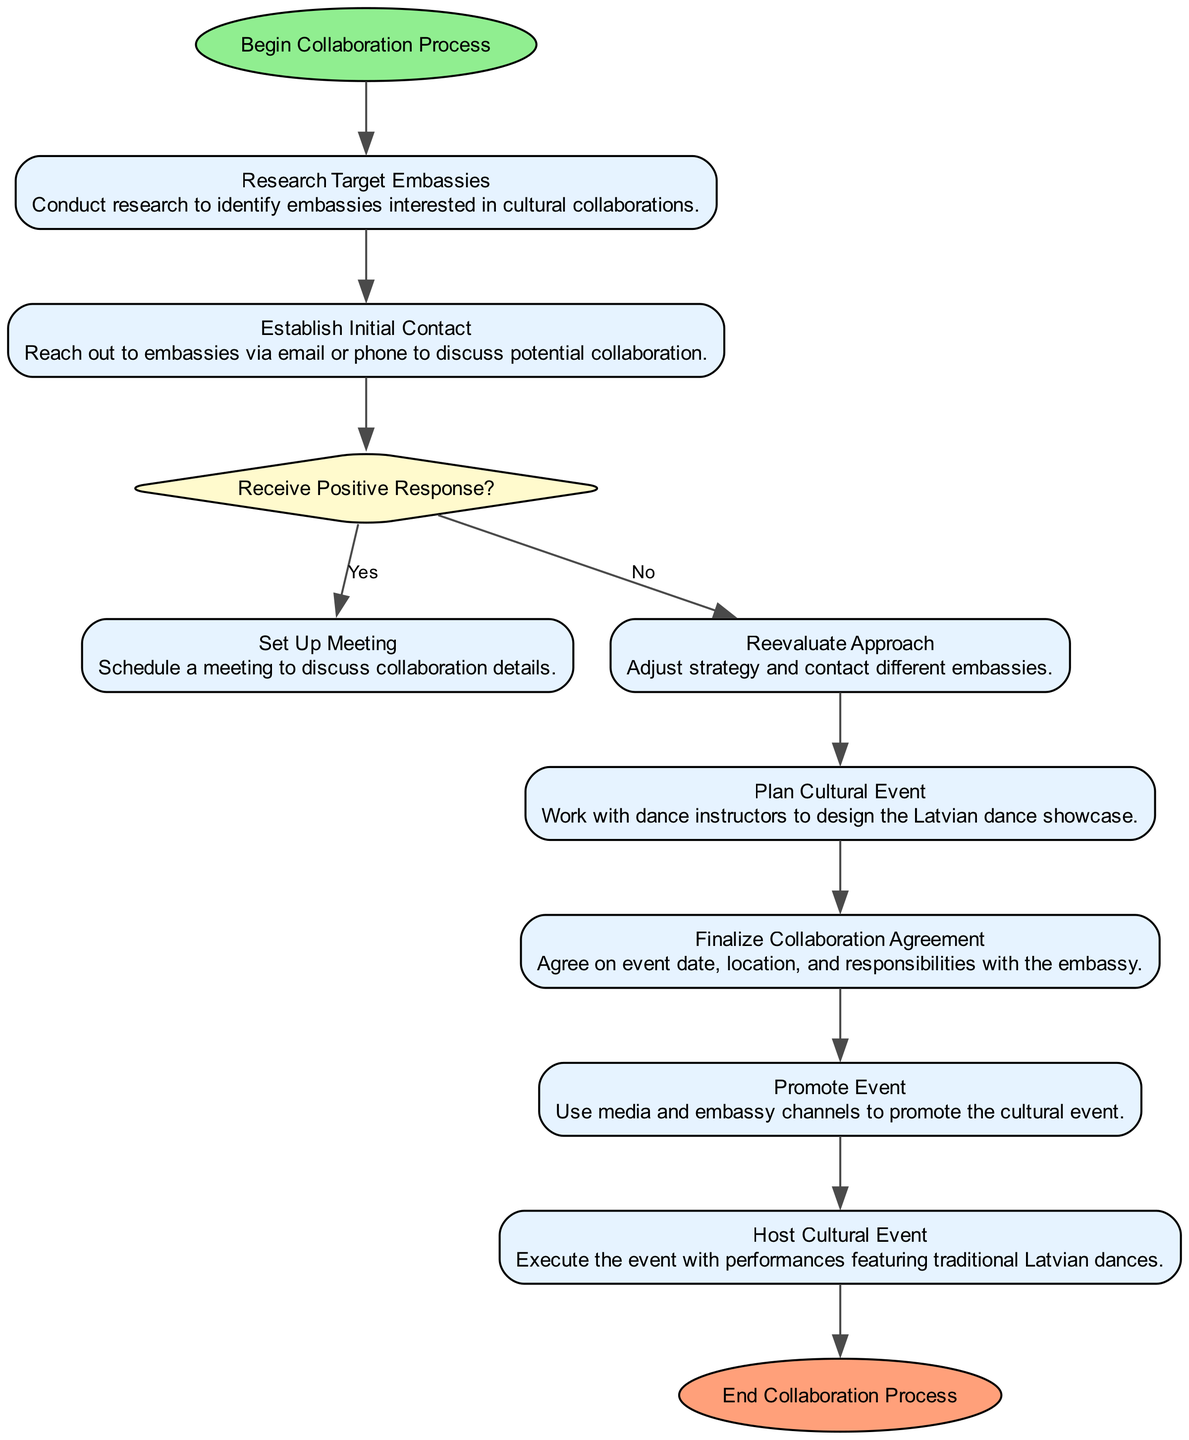What is the first step in the collaboration process? The first step in the process is labeled as "Begin Collaboration Process," which starts the flow of the activity diagram.
Answer: Begin Collaboration Process How many action nodes are in the diagram? By reviewing the diagram, there are six action nodes, which include "Research Target Embassies," "Establish Initial Contact," "Set Up Meeting," "Plan Cultural Event," "Finalize Collaboration Agreement," and "Promote Event."
Answer: Six What happens if the answer to "Receive Positive Response?" is "No"? If the response is "No," the process branches to "Reevaluate Approach," where the strategy is adjusted to contact different embassies, demonstrating an alternative route based on the decision outcome.
Answer: Reevaluate Approach What is the last action before ending the collaboration process? The last action before reaching the "End Collaboration Process" node is "Host Cultural Event," where the actual execution of the event takes place, showcasing the planned performances.
Answer: Host Cultural Event What is the purpose of the "Set Up Meeting" action? The purpose of the "Set Up Meeting" action is to schedule a meeting to discuss the details of the collaboration with the embassy after a positive response is received.
Answer: Schedule a meeting Which action follows the "Finalize Collaboration Agreement"? The action that follows "Finalize Collaboration Agreement" is "Promote Event," as it logically comes after the agreement is in place to start promoting the event.
Answer: Promote Event How does the diagram handle a positive response from embassies? A positive response results in progressing to "Set Up Meeting," indicating that the collaboration is moving forward with logistical discussions while showing the successful continuation of the process.
Answer: Set Up Meeting What type of node comes after "Research Target Embassies"? After "Research Target Embassies," a decision node called "Receive Positive Response?" follows, which determines the next steps based on the response.
Answer: Decision node What does "Plan Cultural Event" entail? "Plan Cultural Event" involves working with dance instructors to design the Latvian dance showcase, which is a critical step for ensuring the cultural event represents Latvian dance accurately.
Answer: Design the Latvian dance showcase 